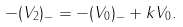<formula> <loc_0><loc_0><loc_500><loc_500>- ( V _ { 2 } ) _ { - } = - ( V _ { 0 } ) _ { - } + k V _ { 0 } .</formula> 